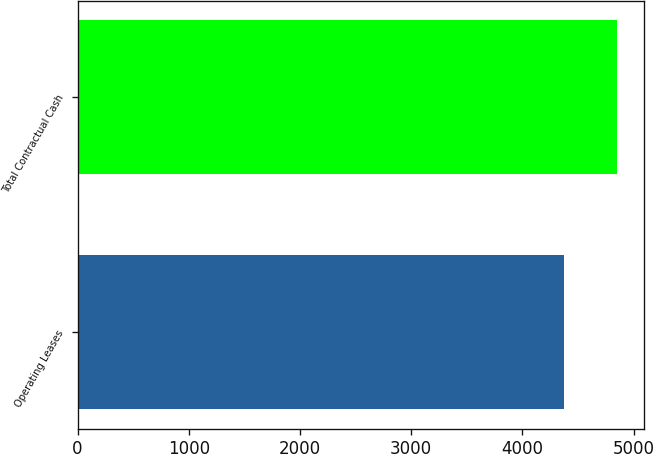Convert chart to OTSL. <chart><loc_0><loc_0><loc_500><loc_500><bar_chart><fcel>Operating Leases<fcel>Total Contractual Cash<nl><fcel>4371<fcel>4851<nl></chart> 